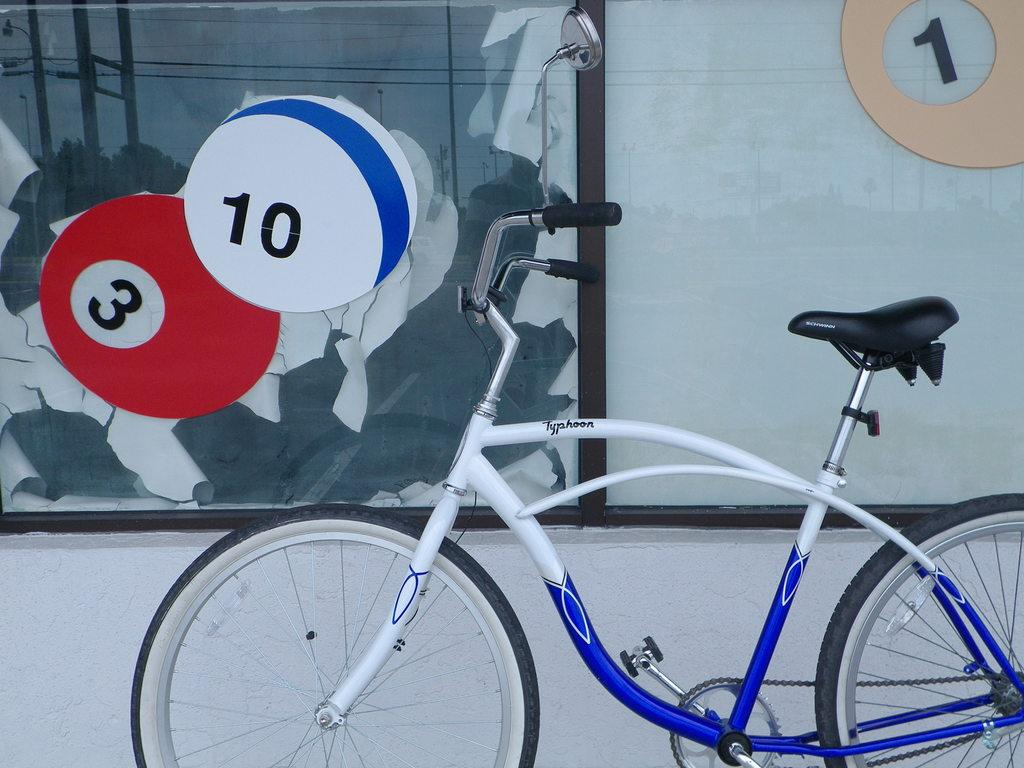What is the main object in the image? There is a bicycle in the image. Where is the bicycle located in relation to other objects? The bicycle is in front of a wall. Can you see a baseball bat in the image? There is no baseball bat present in the image. Is there a nest built on the bicycle in the image? There is no nest present on the bicycle in the image. 